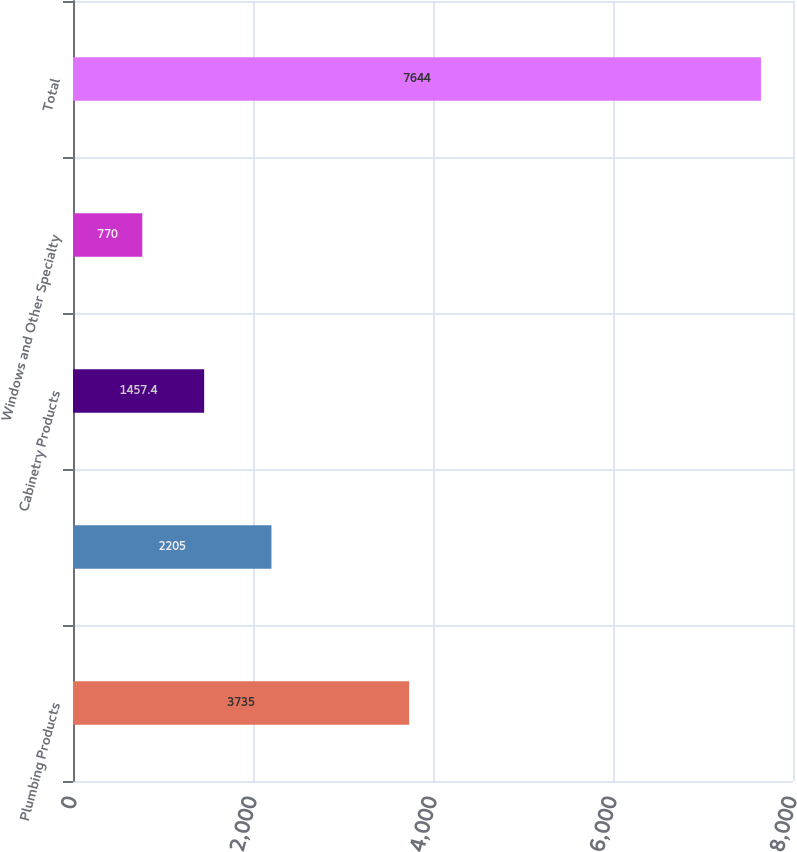<chart> <loc_0><loc_0><loc_500><loc_500><bar_chart><fcel>Plumbing Products<fcel>Unnamed: 1<fcel>Cabinetry Products<fcel>Windows and Other Specialty<fcel>Total<nl><fcel>3735<fcel>2205<fcel>1457.4<fcel>770<fcel>7644<nl></chart> 